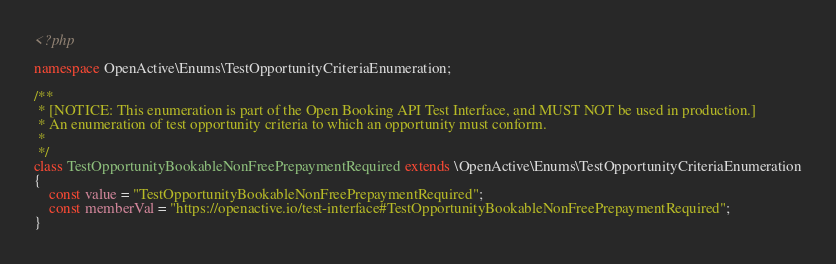Convert code to text. <code><loc_0><loc_0><loc_500><loc_500><_PHP_><?php

namespace OpenActive\Enums\TestOpportunityCriteriaEnumeration;

/**
 * [NOTICE: This enumeration is part of the Open Booking API Test Interface, and MUST NOT be used in production.]
 * An enumeration of test opportunity criteria to which an opportunity must conform.
 *
 */
class TestOpportunityBookableNonFreePrepaymentRequired extends \OpenActive\Enums\TestOpportunityCriteriaEnumeration
{
    const value = "TestOpportunityBookableNonFreePrepaymentRequired";
    const memberVal = "https://openactive.io/test-interface#TestOpportunityBookableNonFreePrepaymentRequired";
}
</code> 